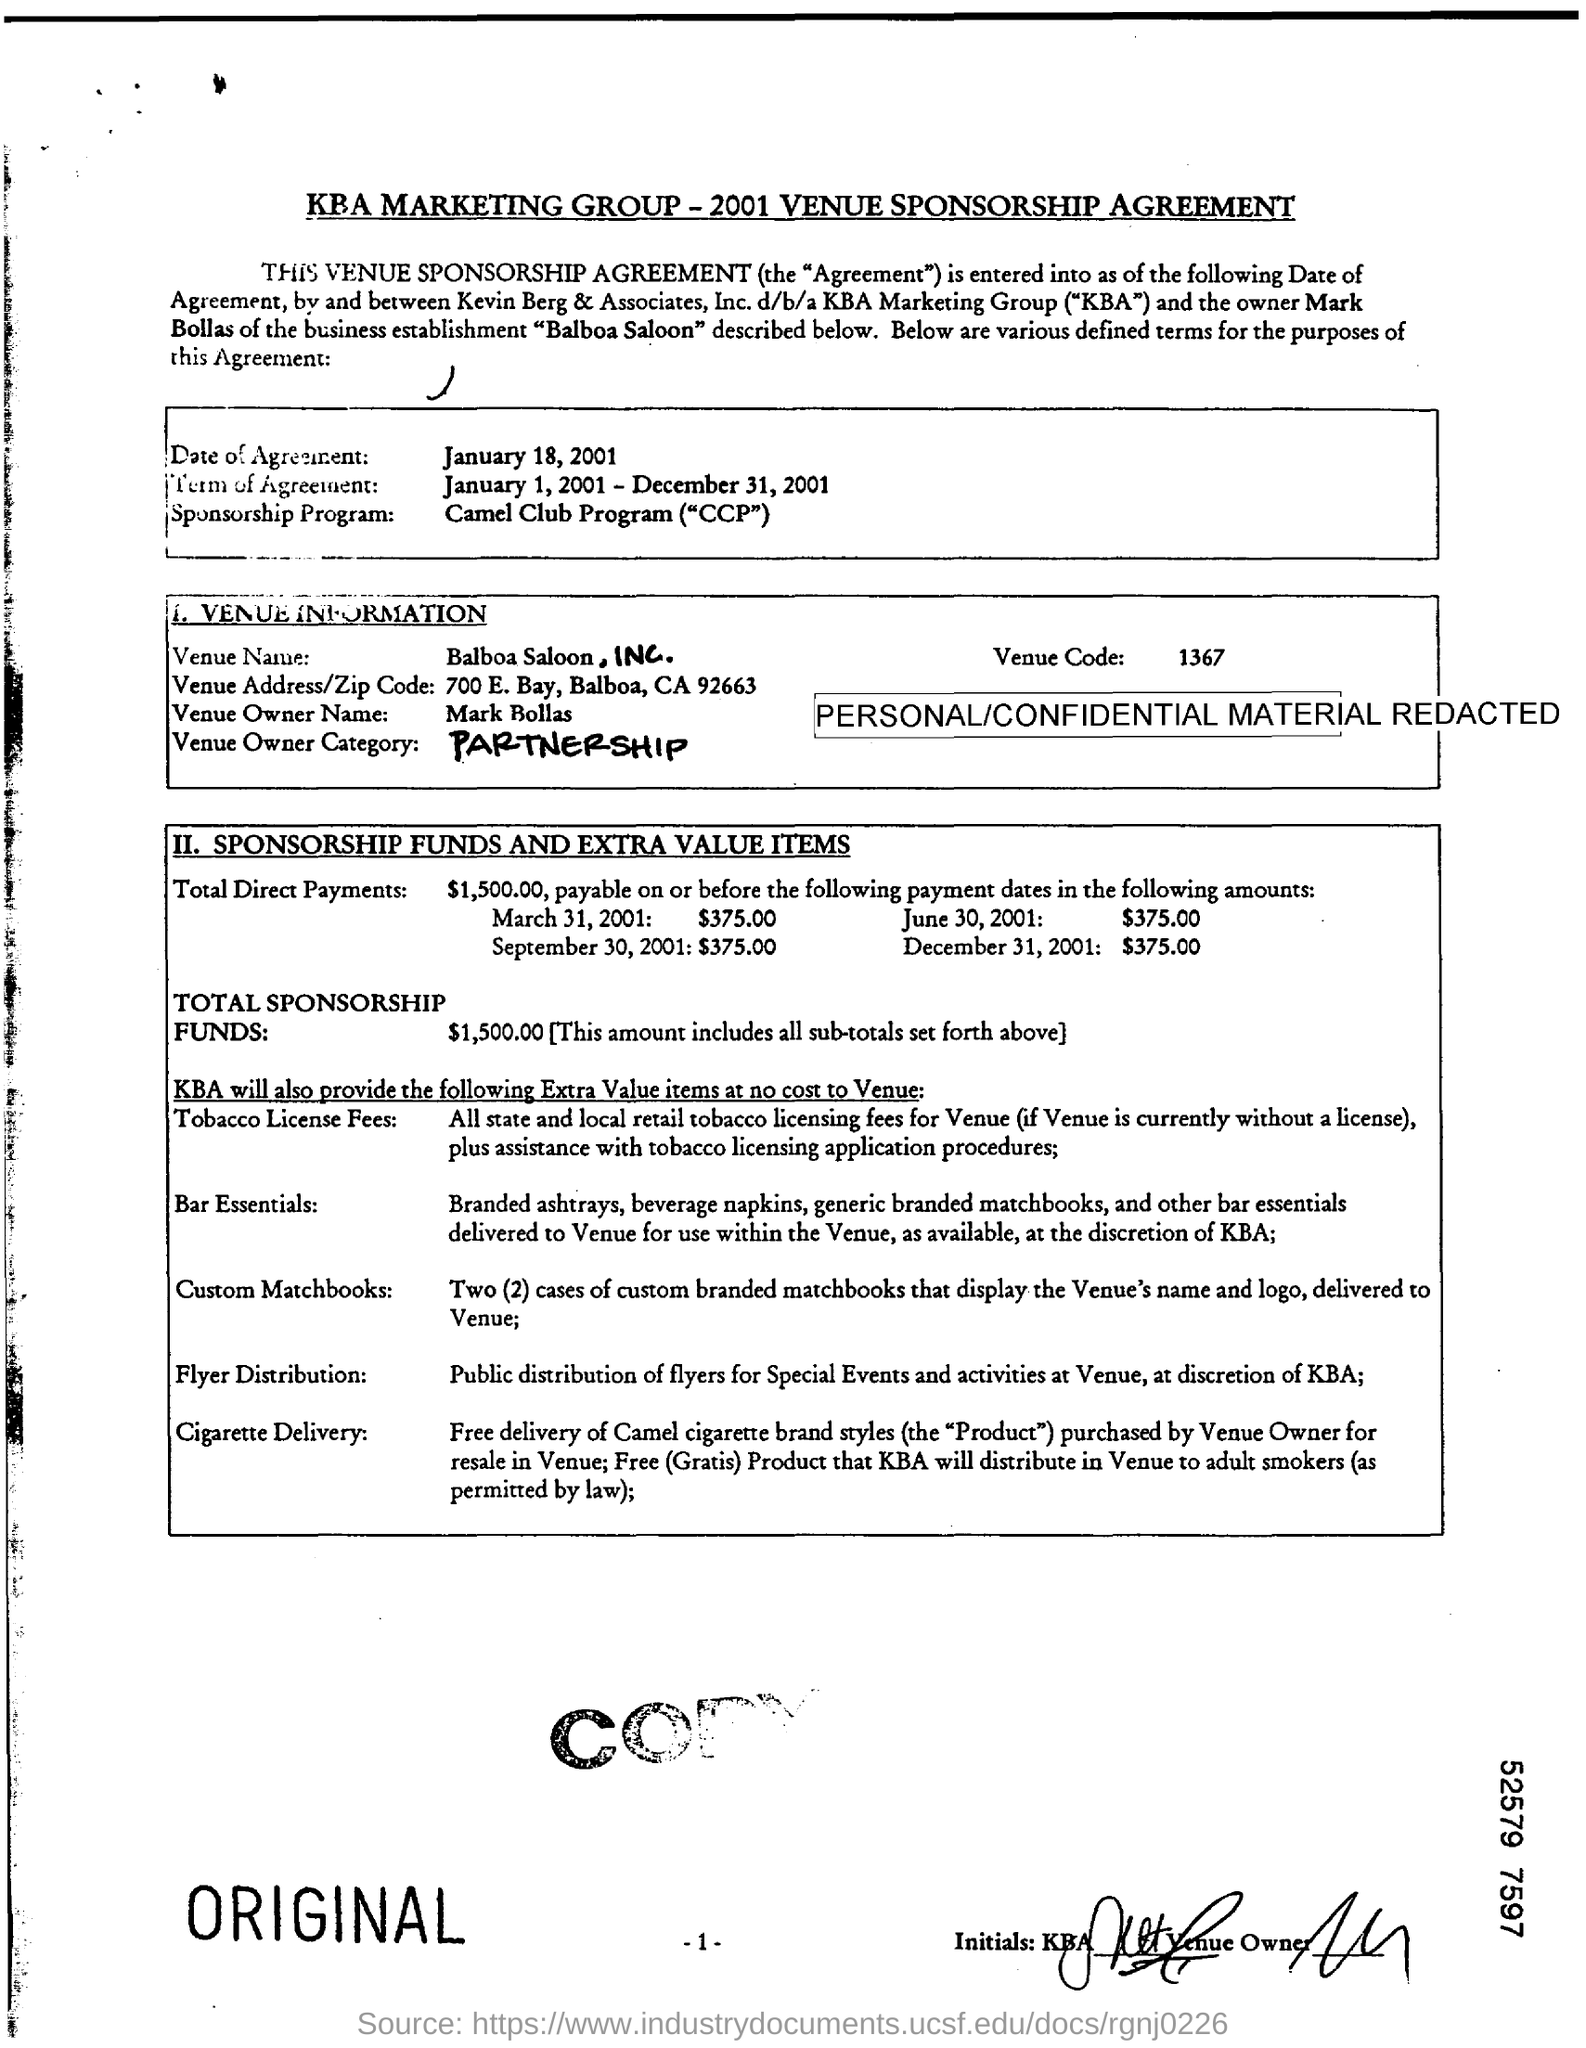Indicate a few pertinent items in this graphic. On January 18, 2001, the date of agreement was reached. The Venue Name is Balboa Saloon, INC. The term of agreement was from January 1, 2001, to December 31, 2001. 